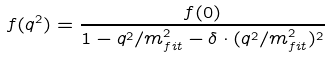Convert formula to latex. <formula><loc_0><loc_0><loc_500><loc_500>f ( q ^ { 2 } ) = \frac { f ( 0 ) } { 1 - q ^ { 2 } / m _ { f i t } ^ { 2 } - \delta \cdot ( q ^ { 2 } / m _ { f i t } ^ { 2 } ) ^ { 2 } }</formula> 